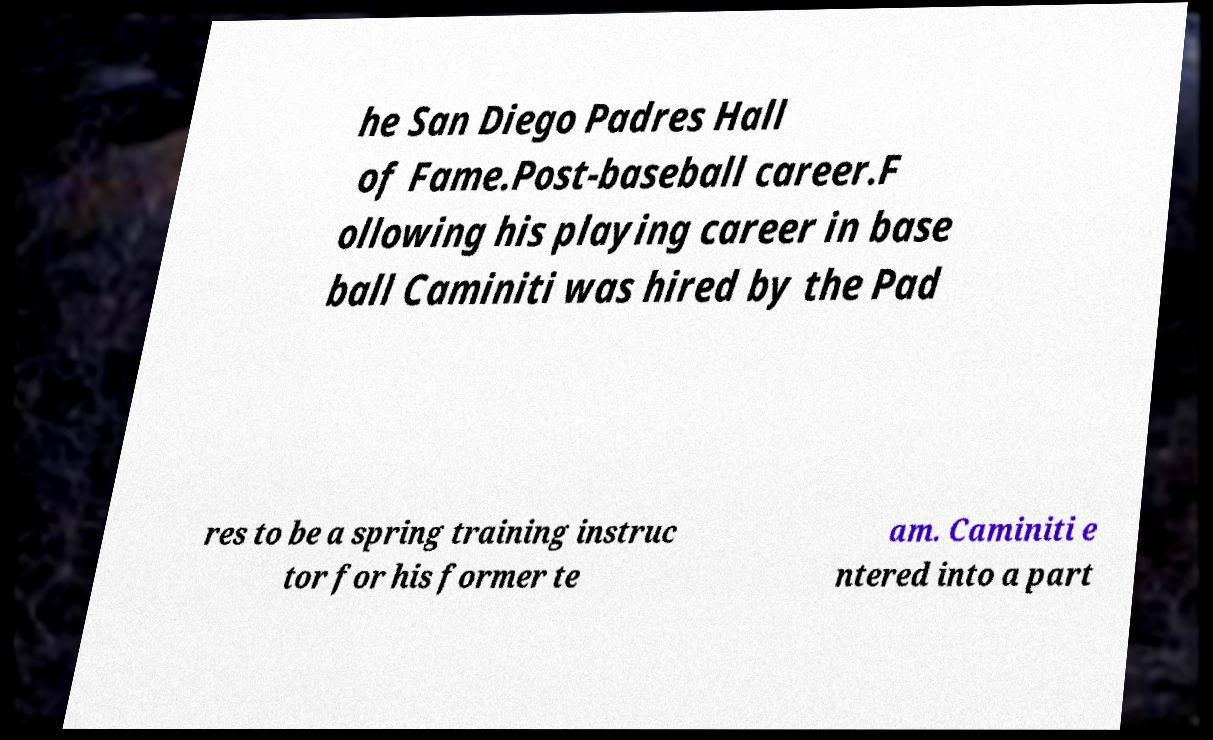Please read and relay the text visible in this image. What does it say? he San Diego Padres Hall of Fame.Post-baseball career.F ollowing his playing career in base ball Caminiti was hired by the Pad res to be a spring training instruc tor for his former te am. Caminiti e ntered into a part 